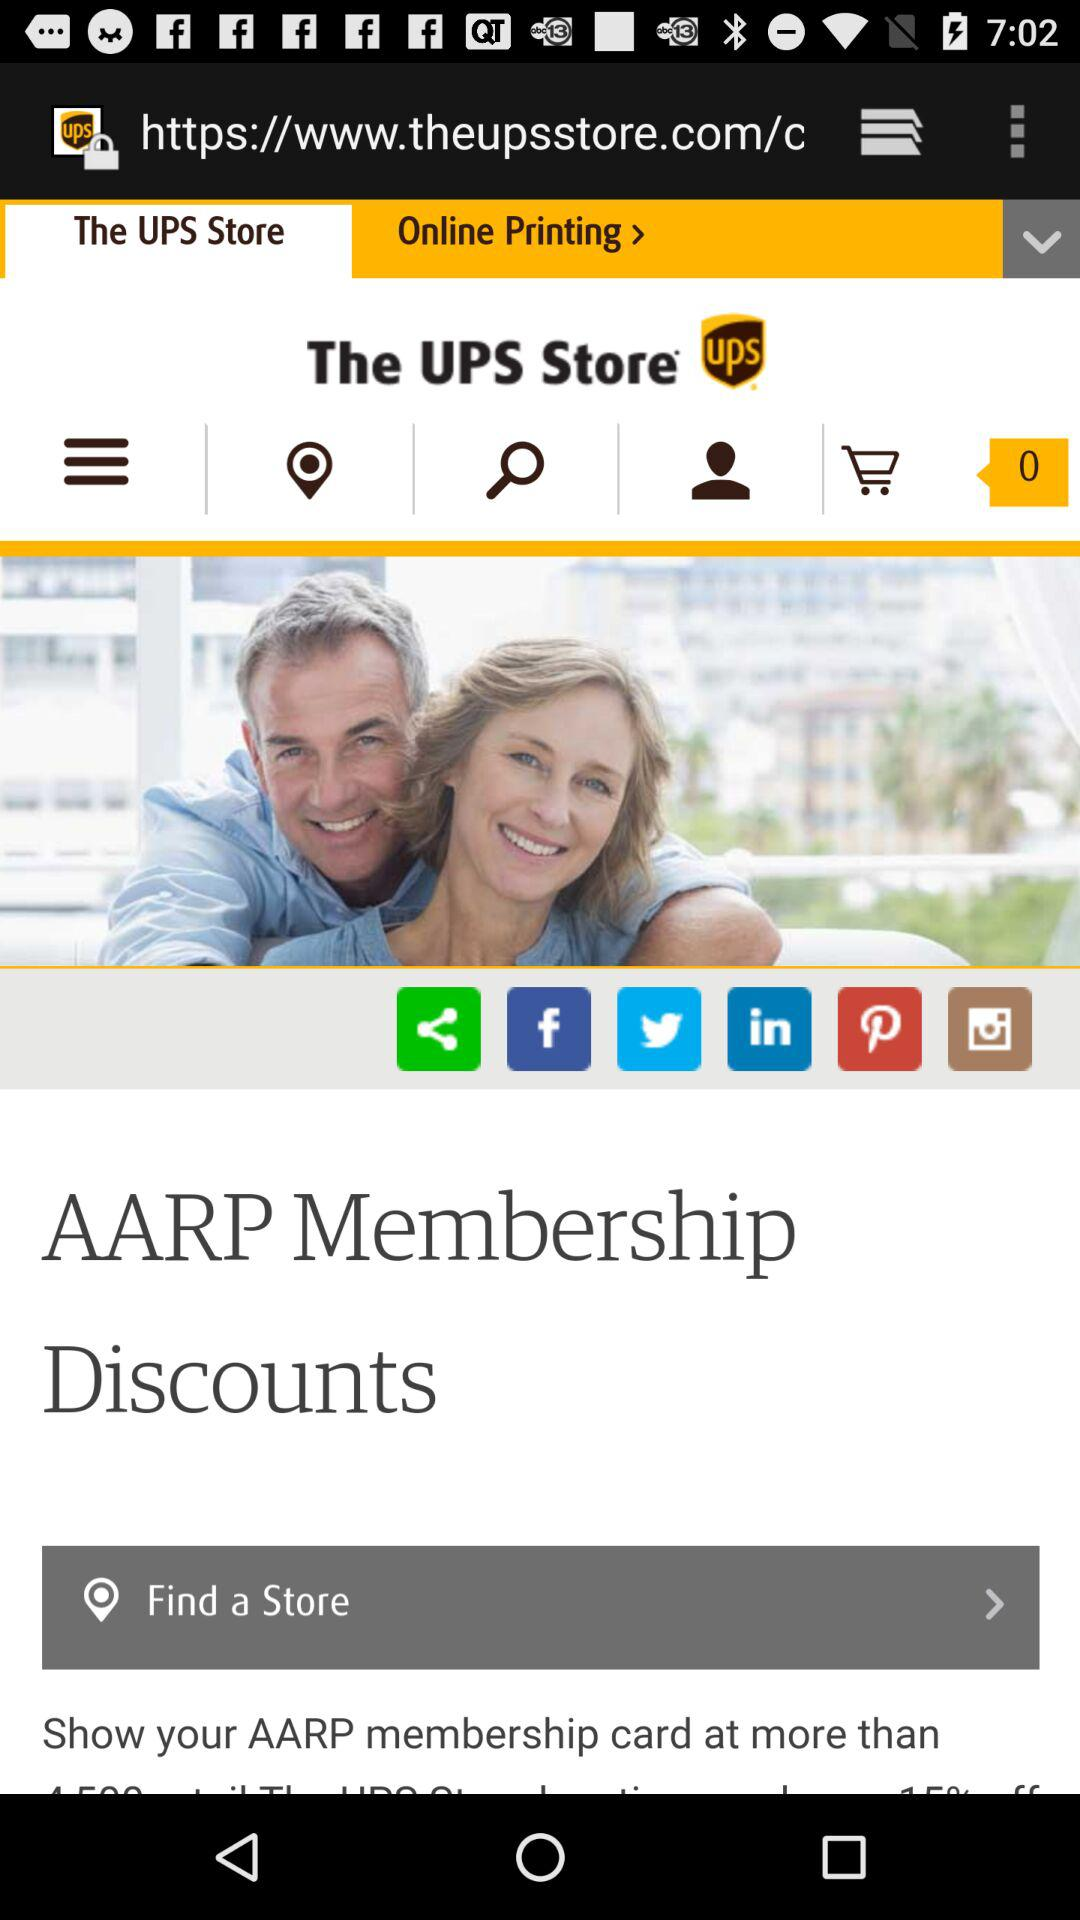How many items are in the cart? There are 0 items in the cart. 